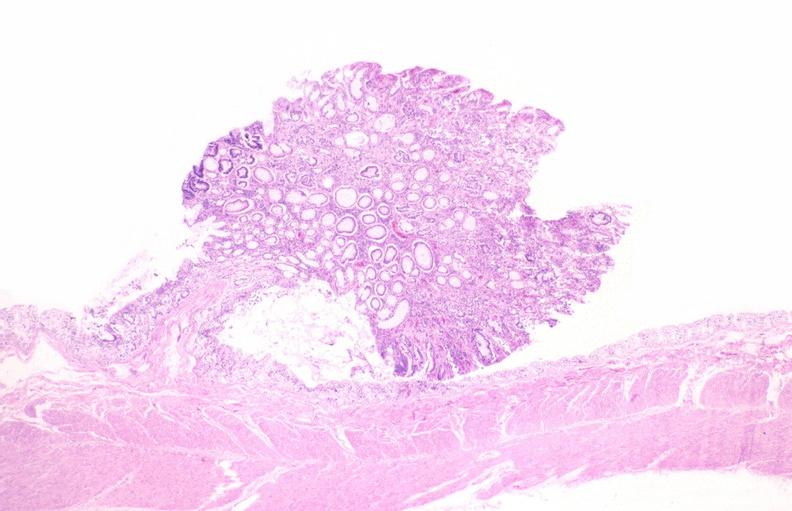s granulomata slide present?
Answer the question using a single word or phrase. No 